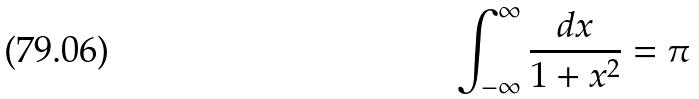Convert formula to latex. <formula><loc_0><loc_0><loc_500><loc_500>\int _ { - \infty } ^ { \infty } \frac { d x } { 1 + x ^ { 2 } } = \pi</formula> 